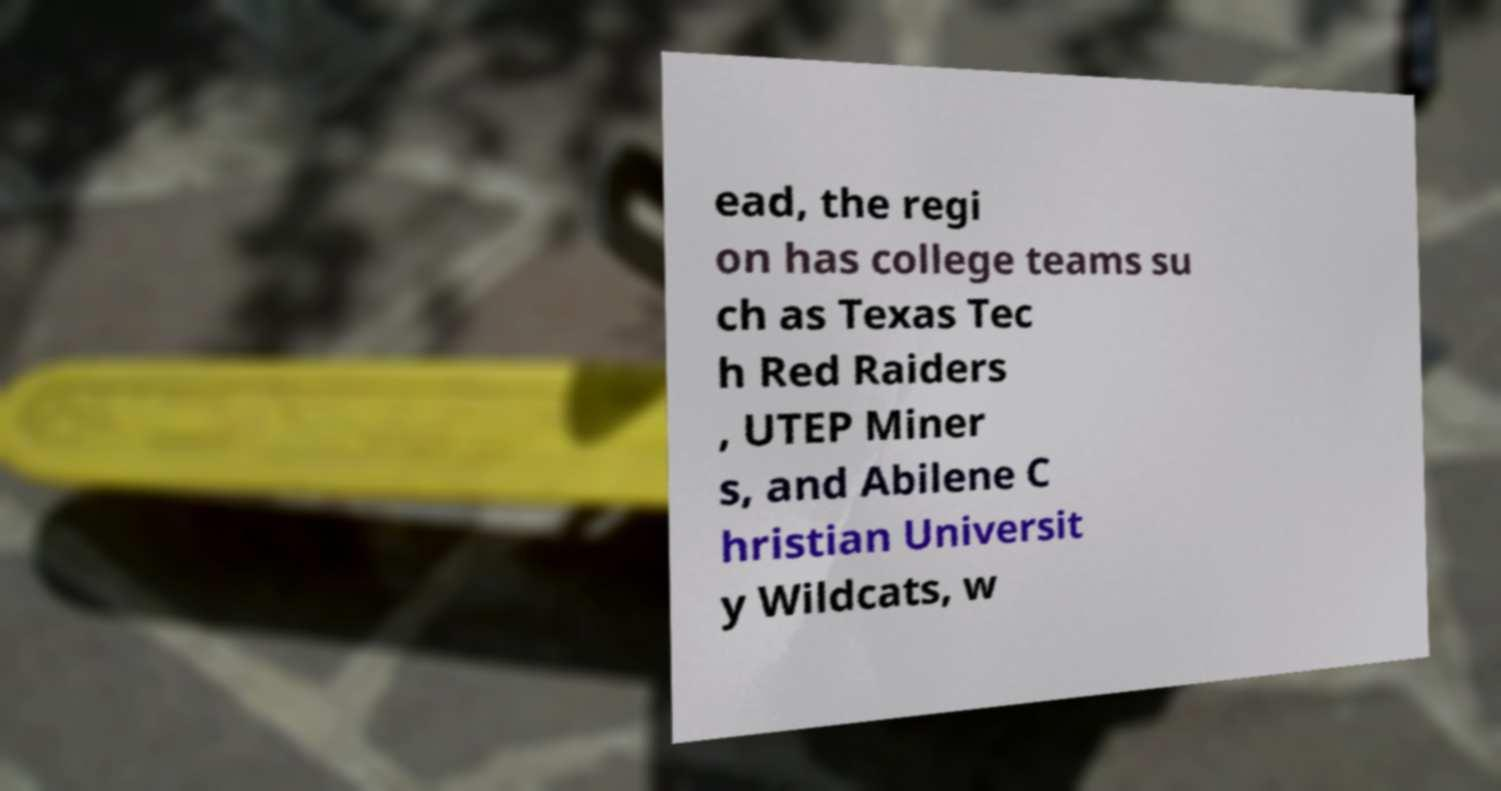What messages or text are displayed in this image? I need them in a readable, typed format. ead, the regi on has college teams su ch as Texas Tec h Red Raiders , UTEP Miner s, and Abilene C hristian Universit y Wildcats, w 